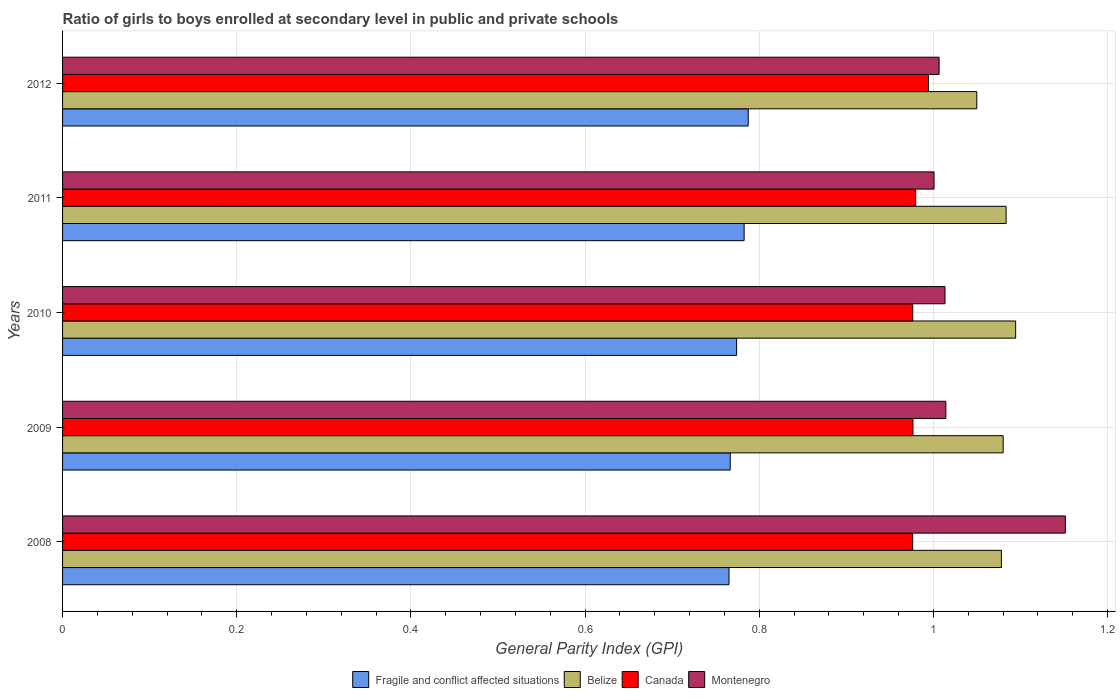How many different coloured bars are there?
Make the answer very short. 4. How many groups of bars are there?
Ensure brevity in your answer.  5. How many bars are there on the 5th tick from the bottom?
Ensure brevity in your answer.  4. In how many cases, is the number of bars for a given year not equal to the number of legend labels?
Your response must be concise. 0. What is the general parity index in Montenegro in 2011?
Provide a short and direct response. 1. Across all years, what is the maximum general parity index in Fragile and conflict affected situations?
Provide a succinct answer. 0.79. Across all years, what is the minimum general parity index in Fragile and conflict affected situations?
Keep it short and to the point. 0.77. In which year was the general parity index in Fragile and conflict affected situations maximum?
Ensure brevity in your answer.  2012. In which year was the general parity index in Montenegro minimum?
Your response must be concise. 2011. What is the total general parity index in Fragile and conflict affected situations in the graph?
Give a very brief answer. 3.88. What is the difference between the general parity index in Fragile and conflict affected situations in 2008 and that in 2010?
Give a very brief answer. -0.01. What is the difference between the general parity index in Belize in 2008 and the general parity index in Canada in 2012?
Give a very brief answer. 0.08. What is the average general parity index in Fragile and conflict affected situations per year?
Your answer should be very brief. 0.78. In the year 2012, what is the difference between the general parity index in Belize and general parity index in Montenegro?
Make the answer very short. 0.04. What is the ratio of the general parity index in Canada in 2009 to that in 2010?
Your answer should be very brief. 1. Is the general parity index in Belize in 2009 less than that in 2012?
Ensure brevity in your answer.  No. Is the difference between the general parity index in Belize in 2010 and 2012 greater than the difference between the general parity index in Montenegro in 2010 and 2012?
Make the answer very short. Yes. What is the difference between the highest and the second highest general parity index in Canada?
Give a very brief answer. 0.01. What is the difference between the highest and the lowest general parity index in Belize?
Make the answer very short. 0.04. Is the sum of the general parity index in Belize in 2009 and 2010 greater than the maximum general parity index in Fragile and conflict affected situations across all years?
Your response must be concise. Yes. Is it the case that in every year, the sum of the general parity index in Belize and general parity index in Fragile and conflict affected situations is greater than the sum of general parity index in Montenegro and general parity index in Canada?
Offer a terse response. No. What does the 3rd bar from the top in 2012 represents?
Ensure brevity in your answer.  Belize. How many bars are there?
Give a very brief answer. 20. Are all the bars in the graph horizontal?
Ensure brevity in your answer.  Yes. How many years are there in the graph?
Your response must be concise. 5. What is the difference between two consecutive major ticks on the X-axis?
Provide a succinct answer. 0.2. Does the graph contain any zero values?
Your response must be concise. No. Where does the legend appear in the graph?
Your response must be concise. Bottom center. How are the legend labels stacked?
Make the answer very short. Horizontal. What is the title of the graph?
Provide a succinct answer. Ratio of girls to boys enrolled at secondary level in public and private schools. What is the label or title of the X-axis?
Your answer should be compact. General Parity Index (GPI). What is the label or title of the Y-axis?
Offer a very short reply. Years. What is the General Parity Index (GPI) of Fragile and conflict affected situations in 2008?
Keep it short and to the point. 0.77. What is the General Parity Index (GPI) in Belize in 2008?
Your response must be concise. 1.08. What is the General Parity Index (GPI) of Canada in 2008?
Your response must be concise. 0.98. What is the General Parity Index (GPI) in Montenegro in 2008?
Give a very brief answer. 1.15. What is the General Parity Index (GPI) in Fragile and conflict affected situations in 2009?
Keep it short and to the point. 0.77. What is the General Parity Index (GPI) in Belize in 2009?
Offer a terse response. 1.08. What is the General Parity Index (GPI) of Canada in 2009?
Your answer should be very brief. 0.98. What is the General Parity Index (GPI) of Montenegro in 2009?
Provide a short and direct response. 1.01. What is the General Parity Index (GPI) in Fragile and conflict affected situations in 2010?
Make the answer very short. 0.77. What is the General Parity Index (GPI) of Belize in 2010?
Keep it short and to the point. 1.09. What is the General Parity Index (GPI) of Canada in 2010?
Provide a short and direct response. 0.98. What is the General Parity Index (GPI) of Montenegro in 2010?
Offer a terse response. 1.01. What is the General Parity Index (GPI) in Fragile and conflict affected situations in 2011?
Offer a terse response. 0.78. What is the General Parity Index (GPI) in Belize in 2011?
Your response must be concise. 1.08. What is the General Parity Index (GPI) in Canada in 2011?
Your answer should be compact. 0.98. What is the General Parity Index (GPI) of Montenegro in 2011?
Offer a very short reply. 1. What is the General Parity Index (GPI) of Fragile and conflict affected situations in 2012?
Offer a terse response. 0.79. What is the General Parity Index (GPI) in Belize in 2012?
Keep it short and to the point. 1.05. What is the General Parity Index (GPI) in Canada in 2012?
Make the answer very short. 0.99. What is the General Parity Index (GPI) in Montenegro in 2012?
Keep it short and to the point. 1.01. Across all years, what is the maximum General Parity Index (GPI) in Fragile and conflict affected situations?
Give a very brief answer. 0.79. Across all years, what is the maximum General Parity Index (GPI) in Belize?
Your response must be concise. 1.09. Across all years, what is the maximum General Parity Index (GPI) of Canada?
Your response must be concise. 0.99. Across all years, what is the maximum General Parity Index (GPI) of Montenegro?
Offer a terse response. 1.15. Across all years, what is the minimum General Parity Index (GPI) in Fragile and conflict affected situations?
Provide a succinct answer. 0.77. Across all years, what is the minimum General Parity Index (GPI) in Belize?
Your answer should be very brief. 1.05. Across all years, what is the minimum General Parity Index (GPI) in Canada?
Keep it short and to the point. 0.98. Across all years, what is the minimum General Parity Index (GPI) of Montenegro?
Give a very brief answer. 1. What is the total General Parity Index (GPI) of Fragile and conflict affected situations in the graph?
Offer a very short reply. 3.88. What is the total General Parity Index (GPI) in Belize in the graph?
Your response must be concise. 5.39. What is the total General Parity Index (GPI) in Canada in the graph?
Your response must be concise. 4.9. What is the total General Parity Index (GPI) of Montenegro in the graph?
Your answer should be compact. 5.19. What is the difference between the General Parity Index (GPI) in Fragile and conflict affected situations in 2008 and that in 2009?
Offer a very short reply. -0. What is the difference between the General Parity Index (GPI) in Belize in 2008 and that in 2009?
Your answer should be compact. -0. What is the difference between the General Parity Index (GPI) of Canada in 2008 and that in 2009?
Your answer should be very brief. -0. What is the difference between the General Parity Index (GPI) of Montenegro in 2008 and that in 2009?
Give a very brief answer. 0.14. What is the difference between the General Parity Index (GPI) in Fragile and conflict affected situations in 2008 and that in 2010?
Make the answer very short. -0.01. What is the difference between the General Parity Index (GPI) of Belize in 2008 and that in 2010?
Give a very brief answer. -0.02. What is the difference between the General Parity Index (GPI) of Canada in 2008 and that in 2010?
Provide a succinct answer. -0. What is the difference between the General Parity Index (GPI) of Montenegro in 2008 and that in 2010?
Your answer should be compact. 0.14. What is the difference between the General Parity Index (GPI) in Fragile and conflict affected situations in 2008 and that in 2011?
Your answer should be very brief. -0.02. What is the difference between the General Parity Index (GPI) of Belize in 2008 and that in 2011?
Provide a succinct answer. -0.01. What is the difference between the General Parity Index (GPI) in Canada in 2008 and that in 2011?
Your answer should be compact. -0. What is the difference between the General Parity Index (GPI) in Montenegro in 2008 and that in 2011?
Ensure brevity in your answer.  0.15. What is the difference between the General Parity Index (GPI) in Fragile and conflict affected situations in 2008 and that in 2012?
Your answer should be very brief. -0.02. What is the difference between the General Parity Index (GPI) in Belize in 2008 and that in 2012?
Provide a short and direct response. 0.03. What is the difference between the General Parity Index (GPI) in Canada in 2008 and that in 2012?
Your answer should be compact. -0.02. What is the difference between the General Parity Index (GPI) of Montenegro in 2008 and that in 2012?
Offer a very short reply. 0.14. What is the difference between the General Parity Index (GPI) of Fragile and conflict affected situations in 2009 and that in 2010?
Provide a short and direct response. -0.01. What is the difference between the General Parity Index (GPI) in Belize in 2009 and that in 2010?
Offer a very short reply. -0.01. What is the difference between the General Parity Index (GPI) of Canada in 2009 and that in 2010?
Keep it short and to the point. 0. What is the difference between the General Parity Index (GPI) in Fragile and conflict affected situations in 2009 and that in 2011?
Offer a terse response. -0.02. What is the difference between the General Parity Index (GPI) in Belize in 2009 and that in 2011?
Provide a succinct answer. -0. What is the difference between the General Parity Index (GPI) of Canada in 2009 and that in 2011?
Give a very brief answer. -0. What is the difference between the General Parity Index (GPI) of Montenegro in 2009 and that in 2011?
Your answer should be compact. 0.01. What is the difference between the General Parity Index (GPI) of Fragile and conflict affected situations in 2009 and that in 2012?
Offer a very short reply. -0.02. What is the difference between the General Parity Index (GPI) of Belize in 2009 and that in 2012?
Give a very brief answer. 0.03. What is the difference between the General Parity Index (GPI) of Canada in 2009 and that in 2012?
Your answer should be very brief. -0.02. What is the difference between the General Parity Index (GPI) in Montenegro in 2009 and that in 2012?
Give a very brief answer. 0.01. What is the difference between the General Parity Index (GPI) in Fragile and conflict affected situations in 2010 and that in 2011?
Provide a succinct answer. -0.01. What is the difference between the General Parity Index (GPI) in Belize in 2010 and that in 2011?
Provide a short and direct response. 0.01. What is the difference between the General Parity Index (GPI) in Canada in 2010 and that in 2011?
Your answer should be very brief. -0. What is the difference between the General Parity Index (GPI) of Montenegro in 2010 and that in 2011?
Your response must be concise. 0.01. What is the difference between the General Parity Index (GPI) in Fragile and conflict affected situations in 2010 and that in 2012?
Your answer should be compact. -0.01. What is the difference between the General Parity Index (GPI) in Belize in 2010 and that in 2012?
Provide a short and direct response. 0.04. What is the difference between the General Parity Index (GPI) in Canada in 2010 and that in 2012?
Offer a very short reply. -0.02. What is the difference between the General Parity Index (GPI) in Montenegro in 2010 and that in 2012?
Make the answer very short. 0.01. What is the difference between the General Parity Index (GPI) of Fragile and conflict affected situations in 2011 and that in 2012?
Offer a very short reply. -0. What is the difference between the General Parity Index (GPI) in Belize in 2011 and that in 2012?
Offer a very short reply. 0.03. What is the difference between the General Parity Index (GPI) in Canada in 2011 and that in 2012?
Keep it short and to the point. -0.01. What is the difference between the General Parity Index (GPI) of Montenegro in 2011 and that in 2012?
Provide a succinct answer. -0.01. What is the difference between the General Parity Index (GPI) in Fragile and conflict affected situations in 2008 and the General Parity Index (GPI) in Belize in 2009?
Provide a short and direct response. -0.31. What is the difference between the General Parity Index (GPI) of Fragile and conflict affected situations in 2008 and the General Parity Index (GPI) of Canada in 2009?
Make the answer very short. -0.21. What is the difference between the General Parity Index (GPI) in Fragile and conflict affected situations in 2008 and the General Parity Index (GPI) in Montenegro in 2009?
Keep it short and to the point. -0.25. What is the difference between the General Parity Index (GPI) of Belize in 2008 and the General Parity Index (GPI) of Canada in 2009?
Keep it short and to the point. 0.1. What is the difference between the General Parity Index (GPI) of Belize in 2008 and the General Parity Index (GPI) of Montenegro in 2009?
Give a very brief answer. 0.06. What is the difference between the General Parity Index (GPI) of Canada in 2008 and the General Parity Index (GPI) of Montenegro in 2009?
Ensure brevity in your answer.  -0.04. What is the difference between the General Parity Index (GPI) in Fragile and conflict affected situations in 2008 and the General Parity Index (GPI) in Belize in 2010?
Ensure brevity in your answer.  -0.33. What is the difference between the General Parity Index (GPI) in Fragile and conflict affected situations in 2008 and the General Parity Index (GPI) in Canada in 2010?
Your answer should be very brief. -0.21. What is the difference between the General Parity Index (GPI) of Fragile and conflict affected situations in 2008 and the General Parity Index (GPI) of Montenegro in 2010?
Make the answer very short. -0.25. What is the difference between the General Parity Index (GPI) in Belize in 2008 and the General Parity Index (GPI) in Canada in 2010?
Offer a very short reply. 0.1. What is the difference between the General Parity Index (GPI) of Belize in 2008 and the General Parity Index (GPI) of Montenegro in 2010?
Your response must be concise. 0.06. What is the difference between the General Parity Index (GPI) of Canada in 2008 and the General Parity Index (GPI) of Montenegro in 2010?
Your answer should be very brief. -0.04. What is the difference between the General Parity Index (GPI) in Fragile and conflict affected situations in 2008 and the General Parity Index (GPI) in Belize in 2011?
Offer a terse response. -0.32. What is the difference between the General Parity Index (GPI) in Fragile and conflict affected situations in 2008 and the General Parity Index (GPI) in Canada in 2011?
Make the answer very short. -0.21. What is the difference between the General Parity Index (GPI) of Fragile and conflict affected situations in 2008 and the General Parity Index (GPI) of Montenegro in 2011?
Ensure brevity in your answer.  -0.24. What is the difference between the General Parity Index (GPI) in Belize in 2008 and the General Parity Index (GPI) in Canada in 2011?
Offer a very short reply. 0.1. What is the difference between the General Parity Index (GPI) in Belize in 2008 and the General Parity Index (GPI) in Montenegro in 2011?
Keep it short and to the point. 0.08. What is the difference between the General Parity Index (GPI) of Canada in 2008 and the General Parity Index (GPI) of Montenegro in 2011?
Your response must be concise. -0.02. What is the difference between the General Parity Index (GPI) of Fragile and conflict affected situations in 2008 and the General Parity Index (GPI) of Belize in 2012?
Your answer should be very brief. -0.28. What is the difference between the General Parity Index (GPI) in Fragile and conflict affected situations in 2008 and the General Parity Index (GPI) in Canada in 2012?
Keep it short and to the point. -0.23. What is the difference between the General Parity Index (GPI) in Fragile and conflict affected situations in 2008 and the General Parity Index (GPI) in Montenegro in 2012?
Your answer should be compact. -0.24. What is the difference between the General Parity Index (GPI) in Belize in 2008 and the General Parity Index (GPI) in Canada in 2012?
Keep it short and to the point. 0.08. What is the difference between the General Parity Index (GPI) of Belize in 2008 and the General Parity Index (GPI) of Montenegro in 2012?
Ensure brevity in your answer.  0.07. What is the difference between the General Parity Index (GPI) of Canada in 2008 and the General Parity Index (GPI) of Montenegro in 2012?
Provide a succinct answer. -0.03. What is the difference between the General Parity Index (GPI) of Fragile and conflict affected situations in 2009 and the General Parity Index (GPI) of Belize in 2010?
Ensure brevity in your answer.  -0.33. What is the difference between the General Parity Index (GPI) of Fragile and conflict affected situations in 2009 and the General Parity Index (GPI) of Canada in 2010?
Provide a short and direct response. -0.21. What is the difference between the General Parity Index (GPI) in Fragile and conflict affected situations in 2009 and the General Parity Index (GPI) in Montenegro in 2010?
Your answer should be very brief. -0.25. What is the difference between the General Parity Index (GPI) of Belize in 2009 and the General Parity Index (GPI) of Canada in 2010?
Provide a short and direct response. 0.1. What is the difference between the General Parity Index (GPI) of Belize in 2009 and the General Parity Index (GPI) of Montenegro in 2010?
Your response must be concise. 0.07. What is the difference between the General Parity Index (GPI) in Canada in 2009 and the General Parity Index (GPI) in Montenegro in 2010?
Your answer should be compact. -0.04. What is the difference between the General Parity Index (GPI) in Fragile and conflict affected situations in 2009 and the General Parity Index (GPI) in Belize in 2011?
Your response must be concise. -0.32. What is the difference between the General Parity Index (GPI) in Fragile and conflict affected situations in 2009 and the General Parity Index (GPI) in Canada in 2011?
Your answer should be compact. -0.21. What is the difference between the General Parity Index (GPI) in Fragile and conflict affected situations in 2009 and the General Parity Index (GPI) in Montenegro in 2011?
Your response must be concise. -0.23. What is the difference between the General Parity Index (GPI) of Belize in 2009 and the General Parity Index (GPI) of Canada in 2011?
Provide a succinct answer. 0.1. What is the difference between the General Parity Index (GPI) of Belize in 2009 and the General Parity Index (GPI) of Montenegro in 2011?
Give a very brief answer. 0.08. What is the difference between the General Parity Index (GPI) of Canada in 2009 and the General Parity Index (GPI) of Montenegro in 2011?
Your response must be concise. -0.02. What is the difference between the General Parity Index (GPI) in Fragile and conflict affected situations in 2009 and the General Parity Index (GPI) in Belize in 2012?
Provide a succinct answer. -0.28. What is the difference between the General Parity Index (GPI) of Fragile and conflict affected situations in 2009 and the General Parity Index (GPI) of Canada in 2012?
Give a very brief answer. -0.23. What is the difference between the General Parity Index (GPI) of Fragile and conflict affected situations in 2009 and the General Parity Index (GPI) of Montenegro in 2012?
Provide a succinct answer. -0.24. What is the difference between the General Parity Index (GPI) in Belize in 2009 and the General Parity Index (GPI) in Canada in 2012?
Offer a terse response. 0.09. What is the difference between the General Parity Index (GPI) of Belize in 2009 and the General Parity Index (GPI) of Montenegro in 2012?
Ensure brevity in your answer.  0.07. What is the difference between the General Parity Index (GPI) of Canada in 2009 and the General Parity Index (GPI) of Montenegro in 2012?
Provide a succinct answer. -0.03. What is the difference between the General Parity Index (GPI) of Fragile and conflict affected situations in 2010 and the General Parity Index (GPI) of Belize in 2011?
Ensure brevity in your answer.  -0.31. What is the difference between the General Parity Index (GPI) of Fragile and conflict affected situations in 2010 and the General Parity Index (GPI) of Canada in 2011?
Your answer should be compact. -0.21. What is the difference between the General Parity Index (GPI) in Fragile and conflict affected situations in 2010 and the General Parity Index (GPI) in Montenegro in 2011?
Your response must be concise. -0.23. What is the difference between the General Parity Index (GPI) of Belize in 2010 and the General Parity Index (GPI) of Canada in 2011?
Make the answer very short. 0.11. What is the difference between the General Parity Index (GPI) of Belize in 2010 and the General Parity Index (GPI) of Montenegro in 2011?
Provide a short and direct response. 0.09. What is the difference between the General Parity Index (GPI) of Canada in 2010 and the General Parity Index (GPI) of Montenegro in 2011?
Your answer should be compact. -0.02. What is the difference between the General Parity Index (GPI) of Fragile and conflict affected situations in 2010 and the General Parity Index (GPI) of Belize in 2012?
Offer a very short reply. -0.28. What is the difference between the General Parity Index (GPI) in Fragile and conflict affected situations in 2010 and the General Parity Index (GPI) in Canada in 2012?
Provide a succinct answer. -0.22. What is the difference between the General Parity Index (GPI) of Fragile and conflict affected situations in 2010 and the General Parity Index (GPI) of Montenegro in 2012?
Provide a succinct answer. -0.23. What is the difference between the General Parity Index (GPI) of Belize in 2010 and the General Parity Index (GPI) of Canada in 2012?
Your response must be concise. 0.1. What is the difference between the General Parity Index (GPI) of Belize in 2010 and the General Parity Index (GPI) of Montenegro in 2012?
Your response must be concise. 0.09. What is the difference between the General Parity Index (GPI) of Canada in 2010 and the General Parity Index (GPI) of Montenegro in 2012?
Offer a very short reply. -0.03. What is the difference between the General Parity Index (GPI) of Fragile and conflict affected situations in 2011 and the General Parity Index (GPI) of Belize in 2012?
Keep it short and to the point. -0.27. What is the difference between the General Parity Index (GPI) of Fragile and conflict affected situations in 2011 and the General Parity Index (GPI) of Canada in 2012?
Your response must be concise. -0.21. What is the difference between the General Parity Index (GPI) in Fragile and conflict affected situations in 2011 and the General Parity Index (GPI) in Montenegro in 2012?
Keep it short and to the point. -0.22. What is the difference between the General Parity Index (GPI) of Belize in 2011 and the General Parity Index (GPI) of Canada in 2012?
Keep it short and to the point. 0.09. What is the difference between the General Parity Index (GPI) of Belize in 2011 and the General Parity Index (GPI) of Montenegro in 2012?
Give a very brief answer. 0.08. What is the difference between the General Parity Index (GPI) of Canada in 2011 and the General Parity Index (GPI) of Montenegro in 2012?
Your response must be concise. -0.03. What is the average General Parity Index (GPI) in Fragile and conflict affected situations per year?
Offer a very short reply. 0.78. What is the average General Parity Index (GPI) in Belize per year?
Your response must be concise. 1.08. What is the average General Parity Index (GPI) of Canada per year?
Provide a succinct answer. 0.98. What is the average General Parity Index (GPI) of Montenegro per year?
Offer a terse response. 1.04. In the year 2008, what is the difference between the General Parity Index (GPI) in Fragile and conflict affected situations and General Parity Index (GPI) in Belize?
Provide a short and direct response. -0.31. In the year 2008, what is the difference between the General Parity Index (GPI) of Fragile and conflict affected situations and General Parity Index (GPI) of Canada?
Provide a short and direct response. -0.21. In the year 2008, what is the difference between the General Parity Index (GPI) of Fragile and conflict affected situations and General Parity Index (GPI) of Montenegro?
Your answer should be very brief. -0.39. In the year 2008, what is the difference between the General Parity Index (GPI) in Belize and General Parity Index (GPI) in Canada?
Offer a very short reply. 0.1. In the year 2008, what is the difference between the General Parity Index (GPI) in Belize and General Parity Index (GPI) in Montenegro?
Keep it short and to the point. -0.07. In the year 2008, what is the difference between the General Parity Index (GPI) in Canada and General Parity Index (GPI) in Montenegro?
Make the answer very short. -0.18. In the year 2009, what is the difference between the General Parity Index (GPI) of Fragile and conflict affected situations and General Parity Index (GPI) of Belize?
Provide a succinct answer. -0.31. In the year 2009, what is the difference between the General Parity Index (GPI) of Fragile and conflict affected situations and General Parity Index (GPI) of Canada?
Offer a very short reply. -0.21. In the year 2009, what is the difference between the General Parity Index (GPI) of Fragile and conflict affected situations and General Parity Index (GPI) of Montenegro?
Your answer should be very brief. -0.25. In the year 2009, what is the difference between the General Parity Index (GPI) of Belize and General Parity Index (GPI) of Canada?
Your answer should be very brief. 0.1. In the year 2009, what is the difference between the General Parity Index (GPI) of Belize and General Parity Index (GPI) of Montenegro?
Provide a succinct answer. 0.07. In the year 2009, what is the difference between the General Parity Index (GPI) in Canada and General Parity Index (GPI) in Montenegro?
Your response must be concise. -0.04. In the year 2010, what is the difference between the General Parity Index (GPI) in Fragile and conflict affected situations and General Parity Index (GPI) in Belize?
Your response must be concise. -0.32. In the year 2010, what is the difference between the General Parity Index (GPI) of Fragile and conflict affected situations and General Parity Index (GPI) of Canada?
Your answer should be very brief. -0.2. In the year 2010, what is the difference between the General Parity Index (GPI) of Fragile and conflict affected situations and General Parity Index (GPI) of Montenegro?
Your response must be concise. -0.24. In the year 2010, what is the difference between the General Parity Index (GPI) of Belize and General Parity Index (GPI) of Canada?
Provide a short and direct response. 0.12. In the year 2010, what is the difference between the General Parity Index (GPI) in Belize and General Parity Index (GPI) in Montenegro?
Make the answer very short. 0.08. In the year 2010, what is the difference between the General Parity Index (GPI) of Canada and General Parity Index (GPI) of Montenegro?
Offer a terse response. -0.04. In the year 2011, what is the difference between the General Parity Index (GPI) in Fragile and conflict affected situations and General Parity Index (GPI) in Belize?
Provide a succinct answer. -0.3. In the year 2011, what is the difference between the General Parity Index (GPI) in Fragile and conflict affected situations and General Parity Index (GPI) in Canada?
Make the answer very short. -0.2. In the year 2011, what is the difference between the General Parity Index (GPI) of Fragile and conflict affected situations and General Parity Index (GPI) of Montenegro?
Provide a succinct answer. -0.22. In the year 2011, what is the difference between the General Parity Index (GPI) in Belize and General Parity Index (GPI) in Canada?
Your answer should be compact. 0.1. In the year 2011, what is the difference between the General Parity Index (GPI) of Belize and General Parity Index (GPI) of Montenegro?
Your answer should be compact. 0.08. In the year 2011, what is the difference between the General Parity Index (GPI) in Canada and General Parity Index (GPI) in Montenegro?
Your answer should be very brief. -0.02. In the year 2012, what is the difference between the General Parity Index (GPI) of Fragile and conflict affected situations and General Parity Index (GPI) of Belize?
Give a very brief answer. -0.26. In the year 2012, what is the difference between the General Parity Index (GPI) in Fragile and conflict affected situations and General Parity Index (GPI) in Canada?
Offer a very short reply. -0.21. In the year 2012, what is the difference between the General Parity Index (GPI) in Fragile and conflict affected situations and General Parity Index (GPI) in Montenegro?
Make the answer very short. -0.22. In the year 2012, what is the difference between the General Parity Index (GPI) of Belize and General Parity Index (GPI) of Canada?
Your response must be concise. 0.06. In the year 2012, what is the difference between the General Parity Index (GPI) of Belize and General Parity Index (GPI) of Montenegro?
Keep it short and to the point. 0.04. In the year 2012, what is the difference between the General Parity Index (GPI) in Canada and General Parity Index (GPI) in Montenegro?
Keep it short and to the point. -0.01. What is the ratio of the General Parity Index (GPI) in Belize in 2008 to that in 2009?
Your answer should be very brief. 1. What is the ratio of the General Parity Index (GPI) in Montenegro in 2008 to that in 2009?
Your answer should be compact. 1.14. What is the ratio of the General Parity Index (GPI) of Fragile and conflict affected situations in 2008 to that in 2010?
Provide a succinct answer. 0.99. What is the ratio of the General Parity Index (GPI) in Belize in 2008 to that in 2010?
Offer a terse response. 0.99. What is the ratio of the General Parity Index (GPI) in Montenegro in 2008 to that in 2010?
Provide a succinct answer. 1.14. What is the ratio of the General Parity Index (GPI) of Fragile and conflict affected situations in 2008 to that in 2011?
Your answer should be compact. 0.98. What is the ratio of the General Parity Index (GPI) in Canada in 2008 to that in 2011?
Provide a short and direct response. 1. What is the ratio of the General Parity Index (GPI) in Montenegro in 2008 to that in 2011?
Provide a short and direct response. 1.15. What is the ratio of the General Parity Index (GPI) in Fragile and conflict affected situations in 2008 to that in 2012?
Your response must be concise. 0.97. What is the ratio of the General Parity Index (GPI) of Belize in 2008 to that in 2012?
Ensure brevity in your answer.  1.03. What is the ratio of the General Parity Index (GPI) of Canada in 2008 to that in 2012?
Your response must be concise. 0.98. What is the ratio of the General Parity Index (GPI) in Montenegro in 2008 to that in 2012?
Offer a terse response. 1.14. What is the ratio of the General Parity Index (GPI) of Belize in 2009 to that in 2010?
Provide a short and direct response. 0.99. What is the ratio of the General Parity Index (GPI) of Canada in 2009 to that in 2010?
Offer a very short reply. 1. What is the ratio of the General Parity Index (GPI) of Fragile and conflict affected situations in 2009 to that in 2011?
Your response must be concise. 0.98. What is the ratio of the General Parity Index (GPI) in Belize in 2009 to that in 2011?
Make the answer very short. 1. What is the ratio of the General Parity Index (GPI) of Canada in 2009 to that in 2011?
Your answer should be very brief. 1. What is the ratio of the General Parity Index (GPI) of Montenegro in 2009 to that in 2011?
Give a very brief answer. 1.01. What is the ratio of the General Parity Index (GPI) of Fragile and conflict affected situations in 2009 to that in 2012?
Your answer should be compact. 0.97. What is the ratio of the General Parity Index (GPI) in Belize in 2009 to that in 2012?
Your answer should be compact. 1.03. What is the ratio of the General Parity Index (GPI) in Montenegro in 2009 to that in 2012?
Your answer should be very brief. 1.01. What is the ratio of the General Parity Index (GPI) of Fragile and conflict affected situations in 2010 to that in 2011?
Give a very brief answer. 0.99. What is the ratio of the General Parity Index (GPI) of Belize in 2010 to that in 2011?
Your response must be concise. 1.01. What is the ratio of the General Parity Index (GPI) of Montenegro in 2010 to that in 2011?
Keep it short and to the point. 1.01. What is the ratio of the General Parity Index (GPI) of Fragile and conflict affected situations in 2010 to that in 2012?
Offer a very short reply. 0.98. What is the ratio of the General Parity Index (GPI) of Belize in 2010 to that in 2012?
Offer a very short reply. 1.04. What is the ratio of the General Parity Index (GPI) in Canada in 2010 to that in 2012?
Offer a very short reply. 0.98. What is the ratio of the General Parity Index (GPI) in Montenegro in 2010 to that in 2012?
Make the answer very short. 1.01. What is the ratio of the General Parity Index (GPI) in Belize in 2011 to that in 2012?
Offer a terse response. 1.03. What is the ratio of the General Parity Index (GPI) of Canada in 2011 to that in 2012?
Keep it short and to the point. 0.99. What is the ratio of the General Parity Index (GPI) in Montenegro in 2011 to that in 2012?
Your answer should be very brief. 0.99. What is the difference between the highest and the second highest General Parity Index (GPI) of Fragile and conflict affected situations?
Offer a very short reply. 0. What is the difference between the highest and the second highest General Parity Index (GPI) in Belize?
Give a very brief answer. 0.01. What is the difference between the highest and the second highest General Parity Index (GPI) in Canada?
Offer a terse response. 0.01. What is the difference between the highest and the second highest General Parity Index (GPI) in Montenegro?
Keep it short and to the point. 0.14. What is the difference between the highest and the lowest General Parity Index (GPI) of Fragile and conflict affected situations?
Offer a very short reply. 0.02. What is the difference between the highest and the lowest General Parity Index (GPI) of Belize?
Offer a terse response. 0.04. What is the difference between the highest and the lowest General Parity Index (GPI) in Canada?
Keep it short and to the point. 0.02. What is the difference between the highest and the lowest General Parity Index (GPI) in Montenegro?
Offer a terse response. 0.15. 